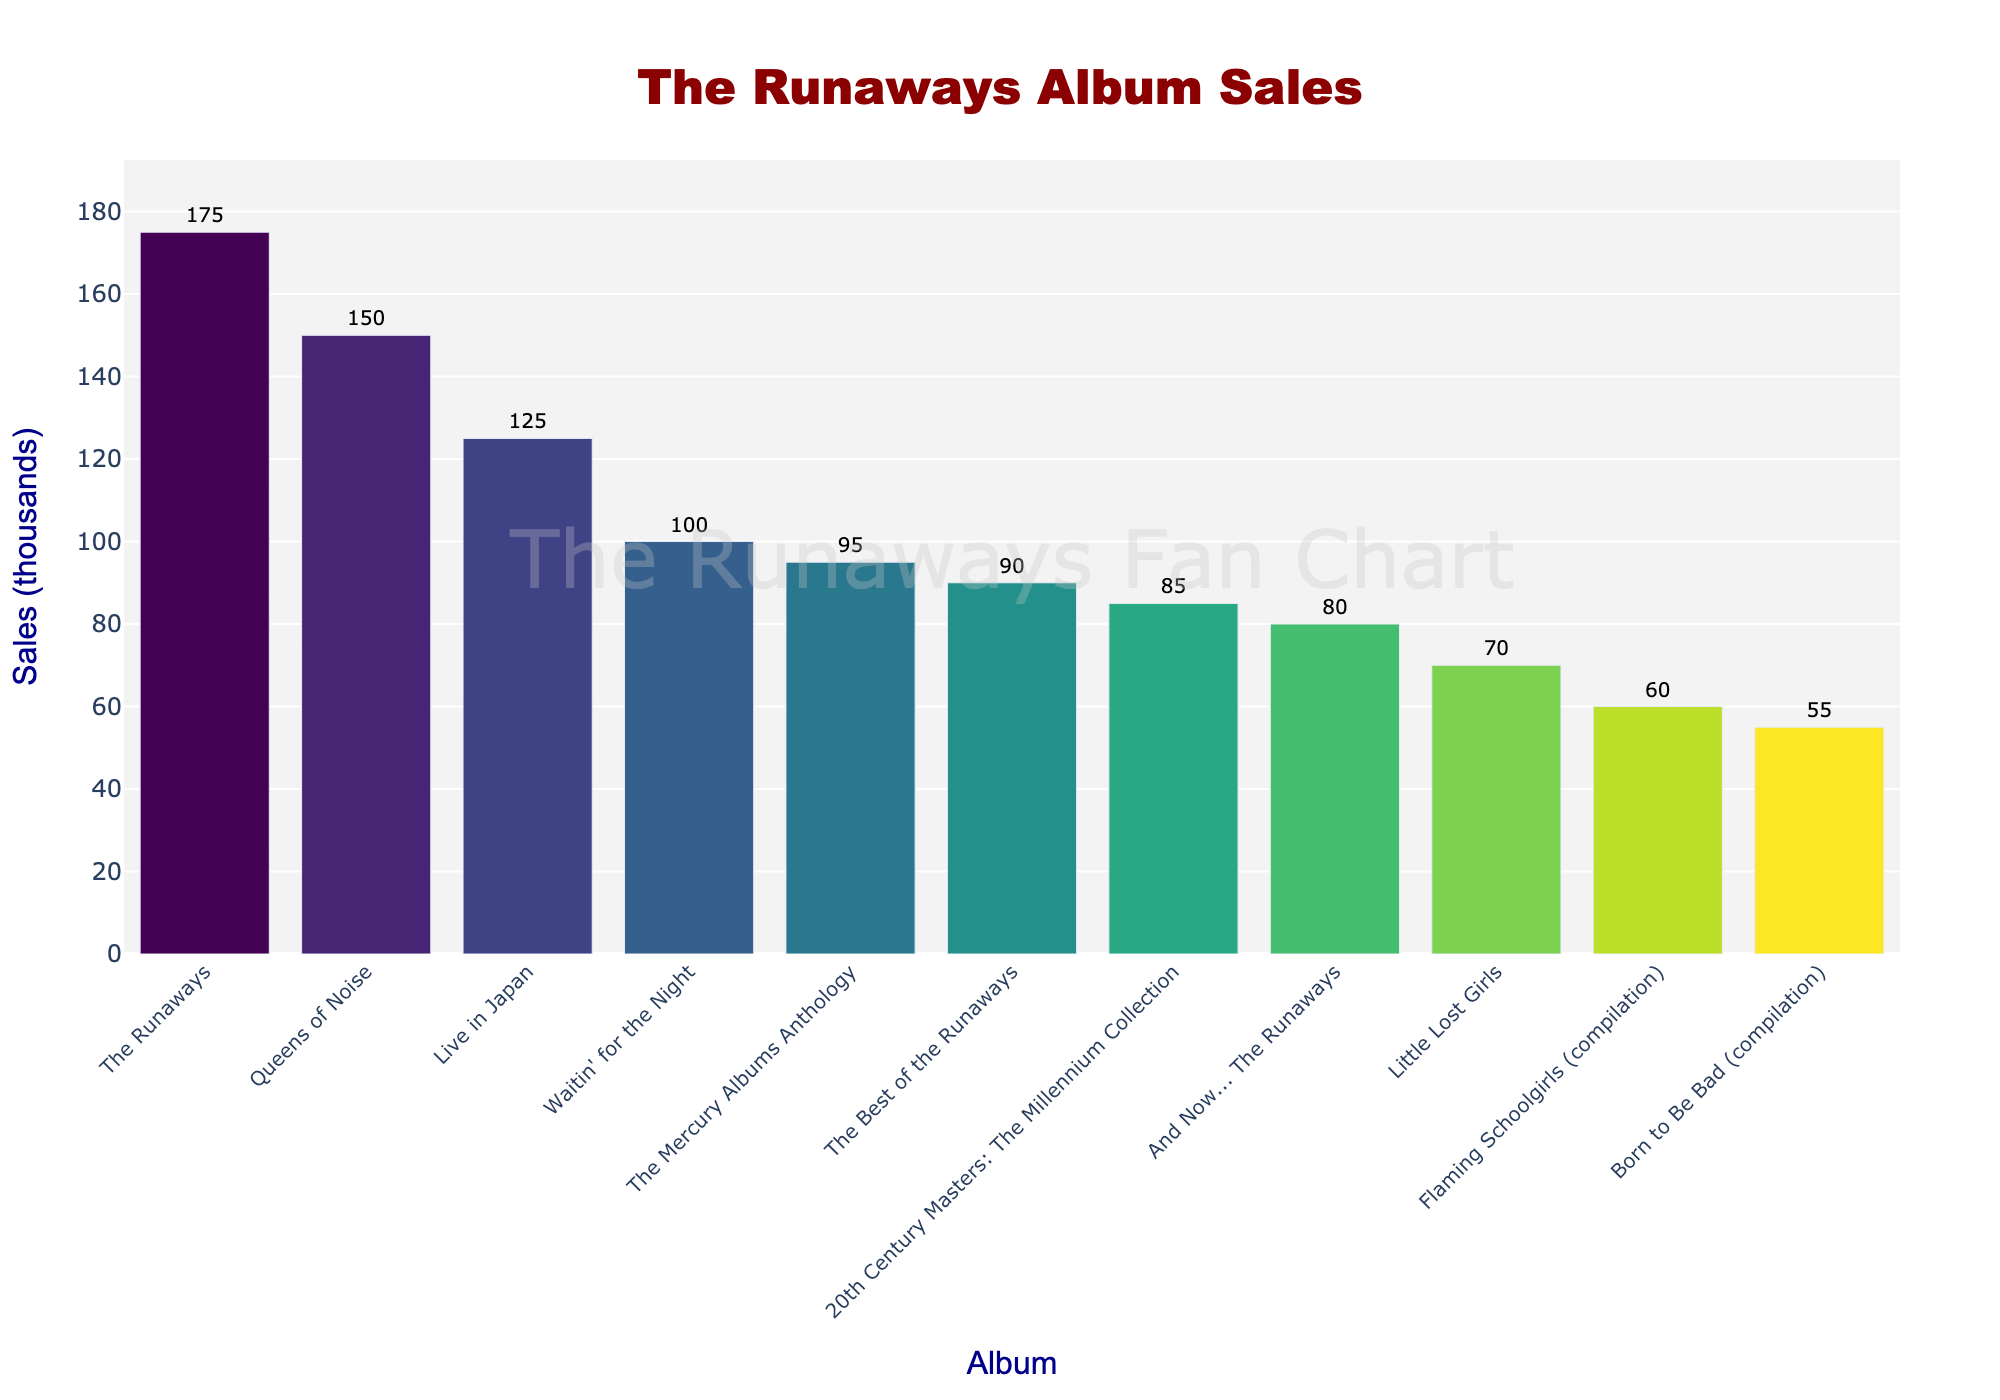What is the highest-selling album by The Runaways? The highest bar represents the highest-selling album. "The Runaways" album has the tallest bar, indicating the highest sales.
Answer: The Runaways Which album has the lowest sales? The shortest bar indicates the album with the lowest sales. "Born to Be Bad (compilation)" is the album with the lowest sales.
Answer: Born to Be Bad (compilation) How much more did "The Runaways" album sell compared to "Queens of Noise"? The sales for "The Runaways" are 175k and for "Queens of Noise" are 150k. The difference is 175k - 150k = 25k.
Answer: 25k Which album has higher sales: "Live in Japan" or "Waitin' for the Night"? Compare the heights of the bars for "Live in Japan" and "Waitin' for the Night". "Live in Japan" has higher sales at 125k compared to "Waitin' for the Night" at 100k.
Answer: Live in Japan What is the total sales for all compilation albums combined? Sum the sales of all compilation albums: "Flaming Schoolgirls" (60k) + "Born to Be Bad" (55k) + "The Best of the Runaways" (90k) + "20th Century Masters" (85k) + "The Mercury Albums Anthology" (95k). 60k + 55k + 90k + 85k + 95k = 385k.
Answer: 385k Which album sales fall closest to the median sales value? After sorting the sales in ascending order: 55k, 60k, 70k, 80k, 85k, 90k, 95k, 100k, 125k, 150k, 175k, the median is the 6th value, which is 90k corresponding to "The Best of the Runaways".
Answer: The Best of the Runaways How do the sales of "And Now... The Runaways" compare to "Little Lost Girls"? The bars show that "And Now... The Runaways" has a height of 80k and "Little Lost Girls" has a height of 70k. 80k is greater than 70k.
Answer: And Now... The Runaways Which album is third highest in sales? The third highest bar in height indicates the third highest sales. "Live in Japan" with 125k in sales is the third highest.
Answer: Live in Japan What is the average sales value across all albums? Sum the sales of all albums and divide by the number of albums. (175k + 150k + 125k + 100k + 80k + 70k + 60k + 55k + 90k + 85k + 95k) / 11 = 1085k / 11 ≈ 98.64k.
Answer: 98.64k 